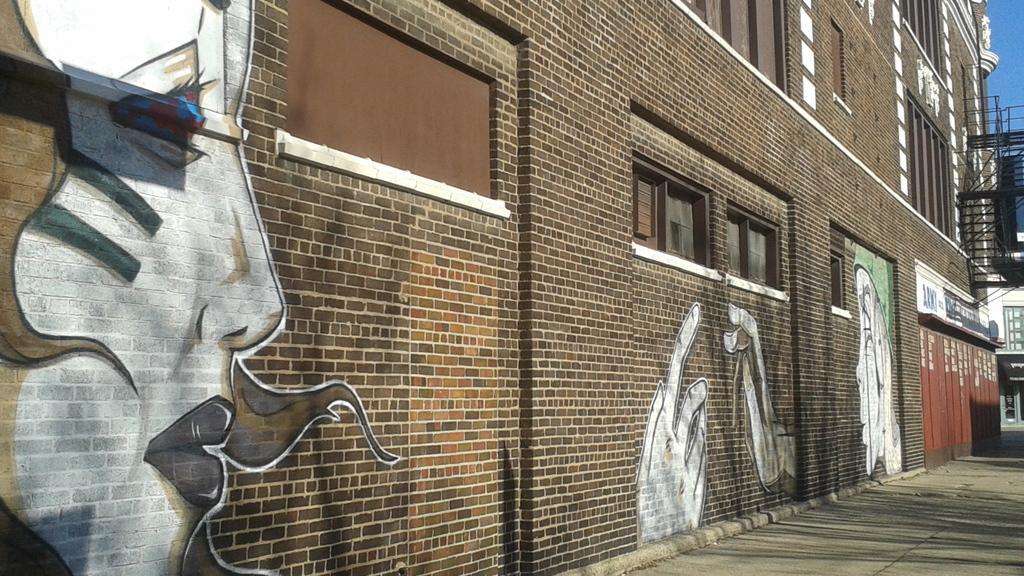Can you describe this image briefly? There are paintings on this wall and there are windows and ventilators to this wall. At the bottom it is the footpath. 